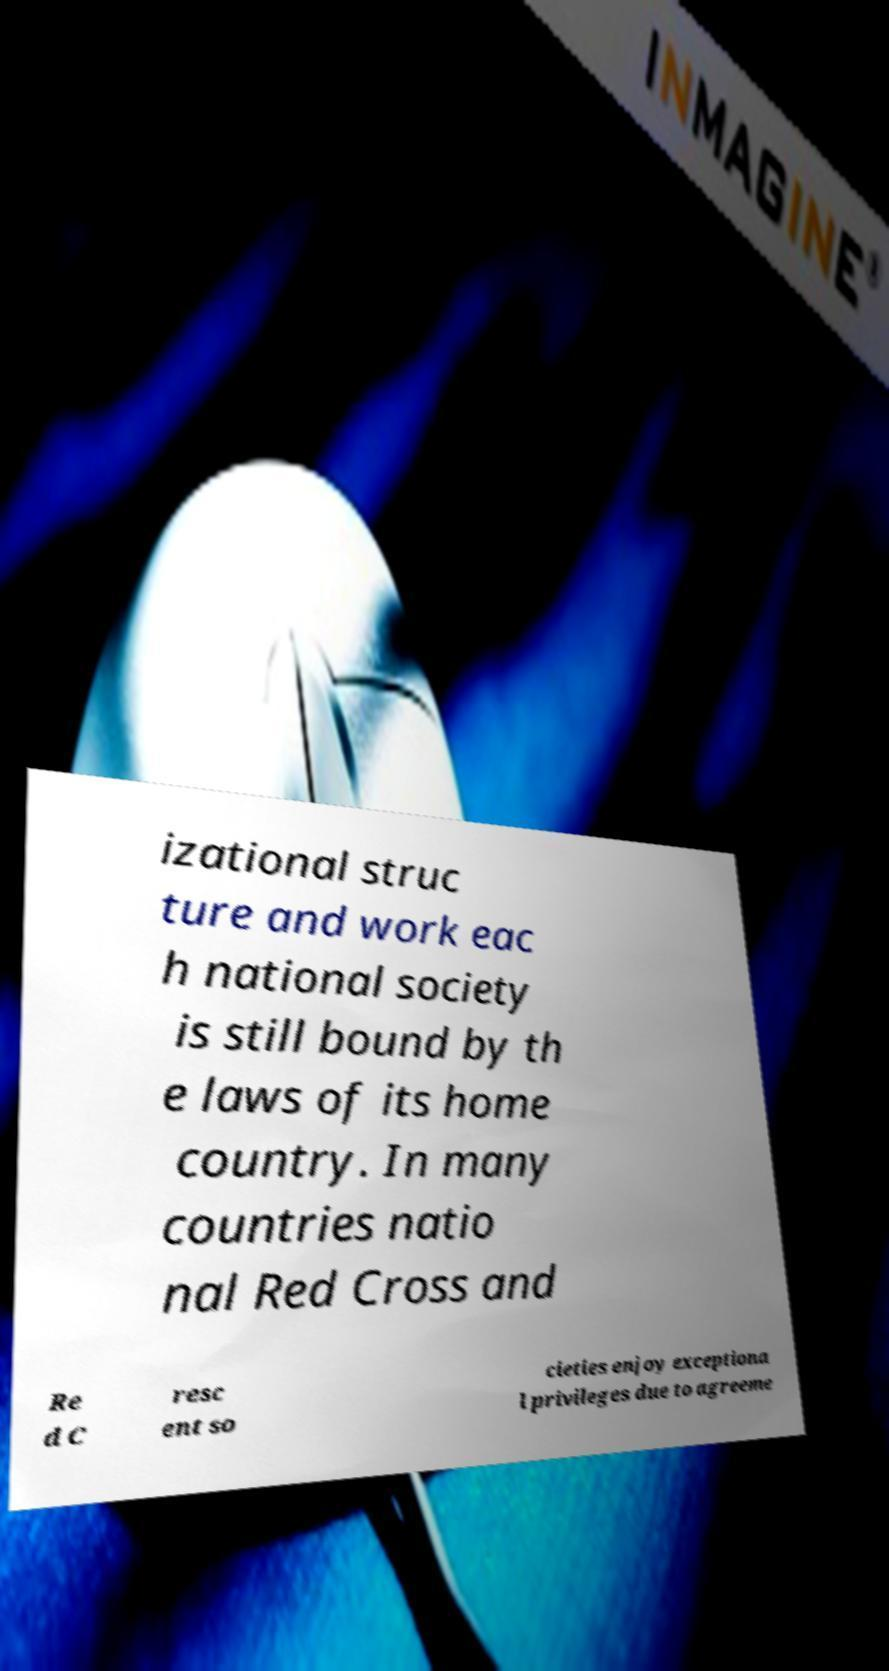I need the written content from this picture converted into text. Can you do that? izational struc ture and work eac h national society is still bound by th e laws of its home country. In many countries natio nal Red Cross and Re d C resc ent so cieties enjoy exceptiona l privileges due to agreeme 